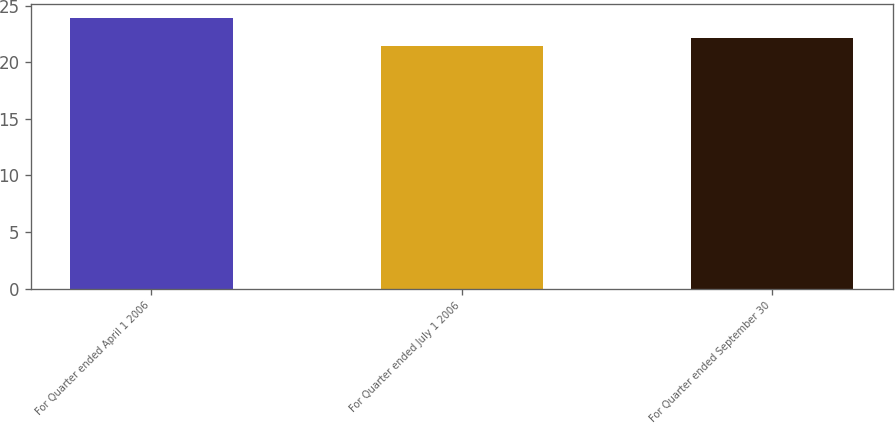Convert chart to OTSL. <chart><loc_0><loc_0><loc_500><loc_500><bar_chart><fcel>For Quarter ended April 1 2006<fcel>For Quarter ended July 1 2006<fcel>For Quarter ended September 30<nl><fcel>23.9<fcel>21.42<fcel>22.12<nl></chart> 